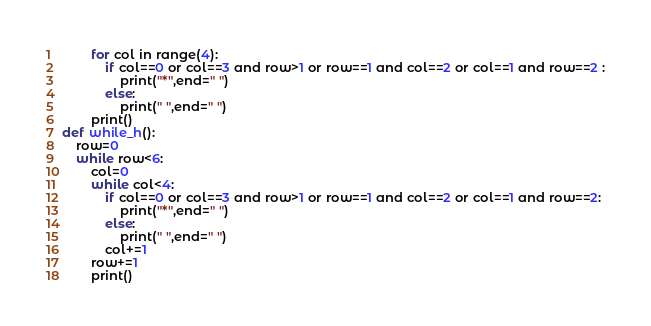<code> <loc_0><loc_0><loc_500><loc_500><_Python_>        for col in range(4):
            if col==0 or col==3 and row>1 or row==1 and col==2 or col==1 and row==2 :
                print("*",end=" ")
            else:
                print(" ",end=" ")
        print()
def while_h():
    row=0
    while row<6:
        col=0
        while col<4:
            if col==0 or col==3 and row>1 or row==1 and col==2 or col==1 and row==2:
                print("*",end=" ")
            else:
                print(" ",end=" ")
            col+=1
        row+=1
        print()        
</code> 